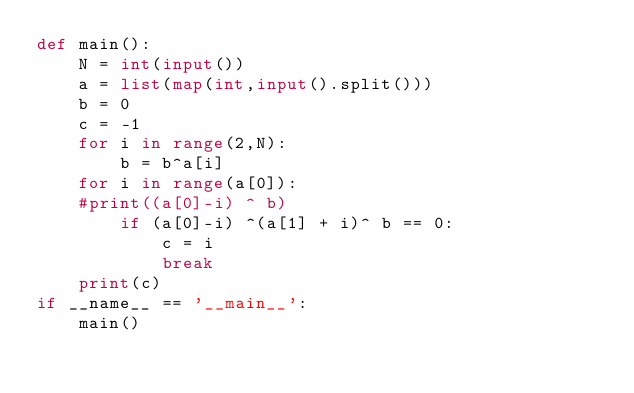Convert code to text. <code><loc_0><loc_0><loc_500><loc_500><_Python_>def main():
	N = int(input())
	a = list(map(int,input().split()))
	b = 0
	c = -1
	for i in range(2,N):
		b = b^a[i]
	for i in range(a[0]):
	#print((a[0]-i) ^ b)
		if (a[0]-i) ^(a[1] + i)^ b == 0:
			c = i
			break
	print(c)
if __name__ == '__main__':
    main()
</code> 